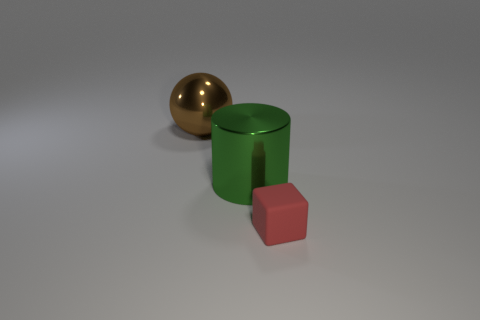Add 2 large green metallic cylinders. How many objects exist? 5 Add 3 blocks. How many blocks exist? 4 Subtract 0 green cubes. How many objects are left? 3 Subtract all balls. How many objects are left? 2 Subtract all tiny purple spheres. Subtract all cubes. How many objects are left? 2 Add 3 matte cubes. How many matte cubes are left? 4 